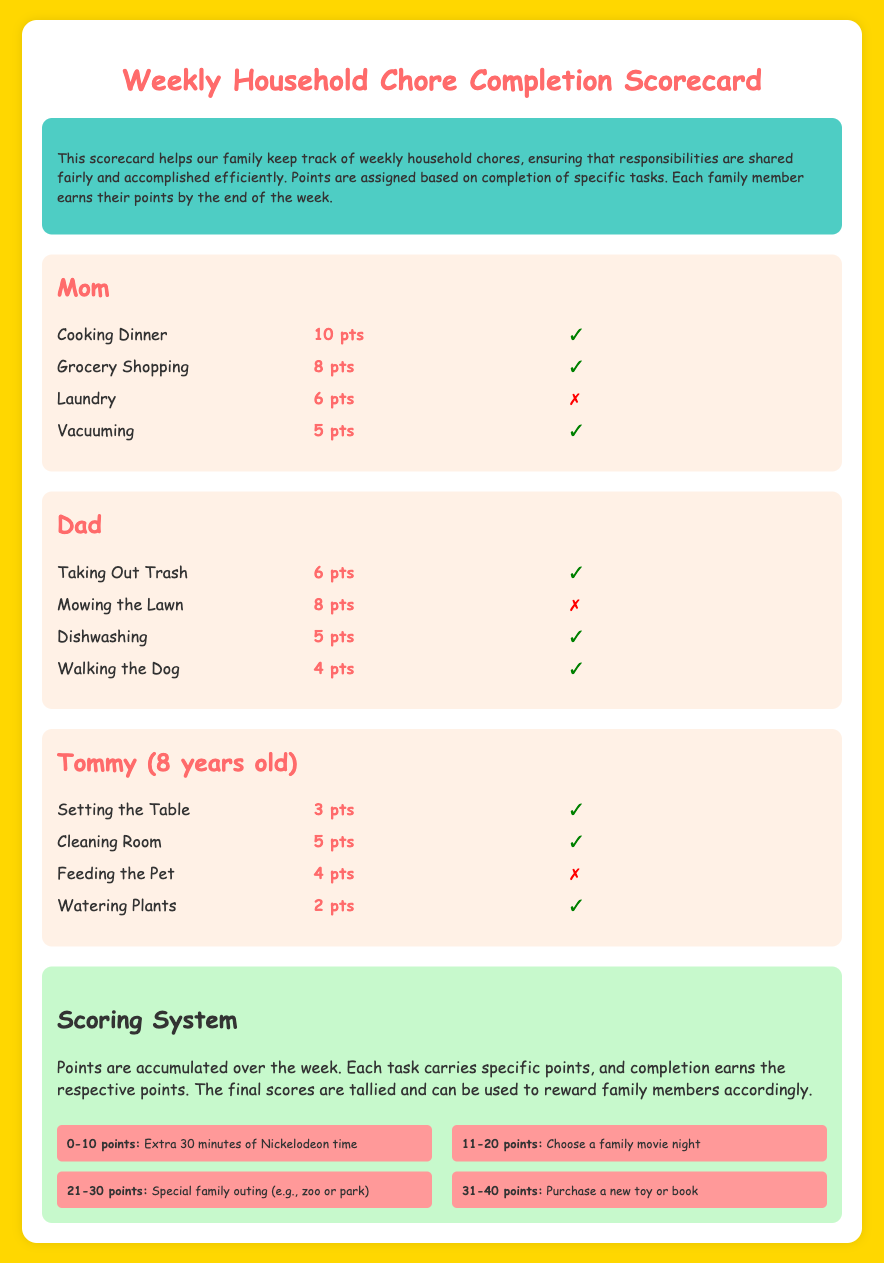What is the total number of points Mom earned? Mom earned points for Cooking Dinner, Grocery Shopping, and Vacuuming, which total 10 + 8 + 5 = 23 points.
Answer: 23 pts How many chores did Tommy complete? Tommy completed Setting the Table, Cleaning Room, and Watering Plants, totaling 3 completed chores.
Answer: 3 What reward can be earned with 0-10 points? The document states that earning 0-10 points qualifies for Extra 30 minutes of Nickelodeon time.
Answer: Extra 30 minutes of Nickelodeon time Which family member did not complete Mowing the Lawn? The document lists Dad as the family member responsible for Mowing the Lawn, which he did not complete.
Answer: Dad What points are awarded for Feeding the Pet? The document specifies that Feeding the Pet is worth 4 points.
Answer: 4 pts What is the color of the background for the scorecard? The background of the scorecard is a shade of gold, specifically #FFD700.
Answer: Gold How many total points did Dad earn? Dad earned points for Taking Out Trash, Dishwashing, and Walking the Dog, totaling 6 + 5 + 4 = 15 points.
Answer: 15 pts Which chore did Mom not complete? The chore that Mom did not complete is Laundry, indicated with a symbol and marked as not completed.
Answer: Laundry 